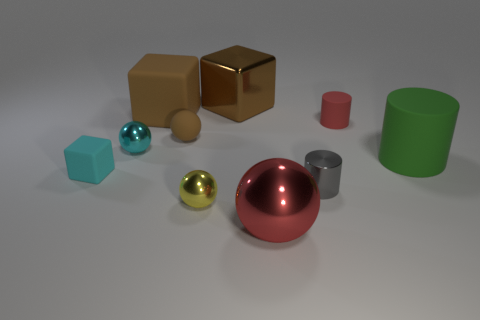What shape is the tiny gray object that is the same material as the cyan sphere?
Offer a very short reply. Cylinder. What number of other things are there of the same shape as the tiny gray object?
Ensure brevity in your answer.  2. There is a big matte thing that is to the left of the big red ball; what shape is it?
Give a very brief answer. Cube. What color is the small matte ball?
Provide a succinct answer. Brown. What number of other objects are the same size as the yellow object?
Your response must be concise. 5. What material is the large brown object left of the brown matte object that is in front of the brown matte cube?
Your response must be concise. Rubber. Is the size of the red rubber cylinder the same as the cube in front of the big green rubber cylinder?
Provide a succinct answer. Yes. Are there any small shiny spheres of the same color as the tiny rubber cube?
Provide a short and direct response. Yes. How many tiny things are red objects or shiny cylinders?
Your answer should be very brief. 2. What number of small red objects are there?
Offer a terse response. 1. 